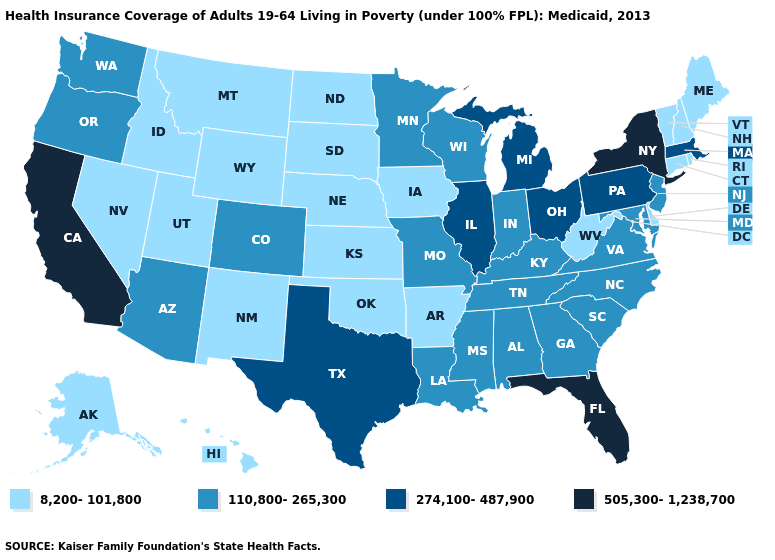Does Kentucky have the lowest value in the South?
Short answer required. No. Does Florida have the highest value in the South?
Write a very short answer. Yes. What is the value of Maryland?
Concise answer only. 110,800-265,300. What is the lowest value in the South?
Be succinct. 8,200-101,800. Name the states that have a value in the range 274,100-487,900?
Be succinct. Illinois, Massachusetts, Michigan, Ohio, Pennsylvania, Texas. Name the states that have a value in the range 8,200-101,800?
Short answer required. Alaska, Arkansas, Connecticut, Delaware, Hawaii, Idaho, Iowa, Kansas, Maine, Montana, Nebraska, Nevada, New Hampshire, New Mexico, North Dakota, Oklahoma, Rhode Island, South Dakota, Utah, Vermont, West Virginia, Wyoming. What is the value of Alabama?
Short answer required. 110,800-265,300. Does California have the same value as Florida?
Be succinct. Yes. Which states have the lowest value in the USA?
Write a very short answer. Alaska, Arkansas, Connecticut, Delaware, Hawaii, Idaho, Iowa, Kansas, Maine, Montana, Nebraska, Nevada, New Hampshire, New Mexico, North Dakota, Oklahoma, Rhode Island, South Dakota, Utah, Vermont, West Virginia, Wyoming. What is the lowest value in states that border Florida?
Short answer required. 110,800-265,300. What is the value of Kentucky?
Keep it brief. 110,800-265,300. What is the value of Florida?
Write a very short answer. 505,300-1,238,700. What is the value of Texas?
Keep it brief. 274,100-487,900. What is the highest value in states that border Delaware?
Write a very short answer. 274,100-487,900. What is the lowest value in the USA?
Write a very short answer. 8,200-101,800. 